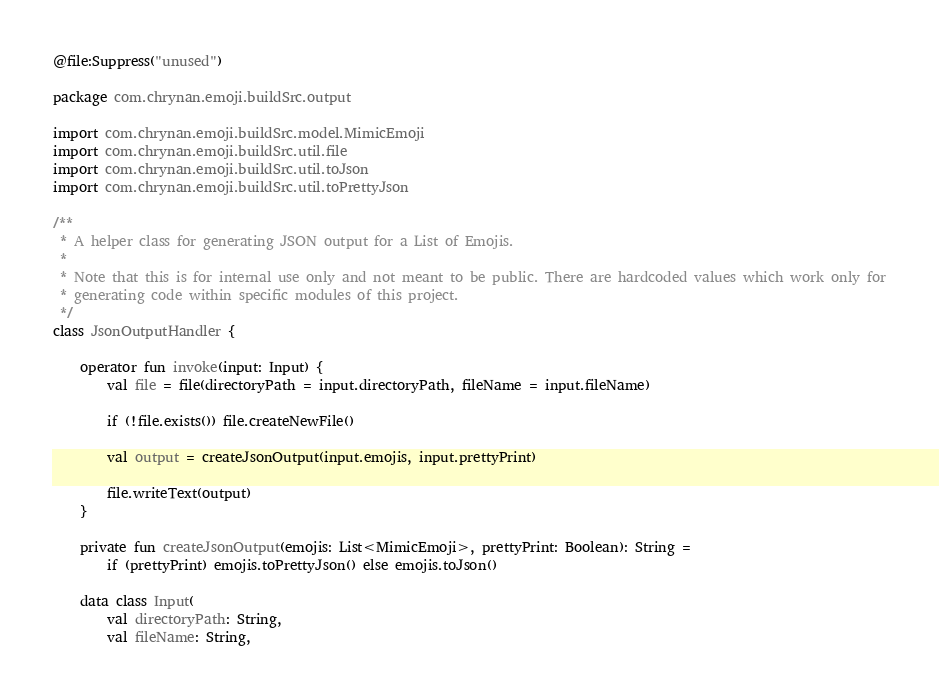Convert code to text. <code><loc_0><loc_0><loc_500><loc_500><_Kotlin_>@file:Suppress("unused")

package com.chrynan.emoji.buildSrc.output

import com.chrynan.emoji.buildSrc.model.MimicEmoji
import com.chrynan.emoji.buildSrc.util.file
import com.chrynan.emoji.buildSrc.util.toJson
import com.chrynan.emoji.buildSrc.util.toPrettyJson

/**
 * A helper class for generating JSON output for a List of Emojis.
 *
 * Note that this is for internal use only and not meant to be public. There are hardcoded values which work only for
 * generating code within specific modules of this project.
 */
class JsonOutputHandler {

    operator fun invoke(input: Input) {
        val file = file(directoryPath = input.directoryPath, fileName = input.fileName)

        if (!file.exists()) file.createNewFile()

        val output = createJsonOutput(input.emojis, input.prettyPrint)

        file.writeText(output)
    }

    private fun createJsonOutput(emojis: List<MimicEmoji>, prettyPrint: Boolean): String =
        if (prettyPrint) emojis.toPrettyJson() else emojis.toJson()

    data class Input(
        val directoryPath: String,
        val fileName: String,</code> 